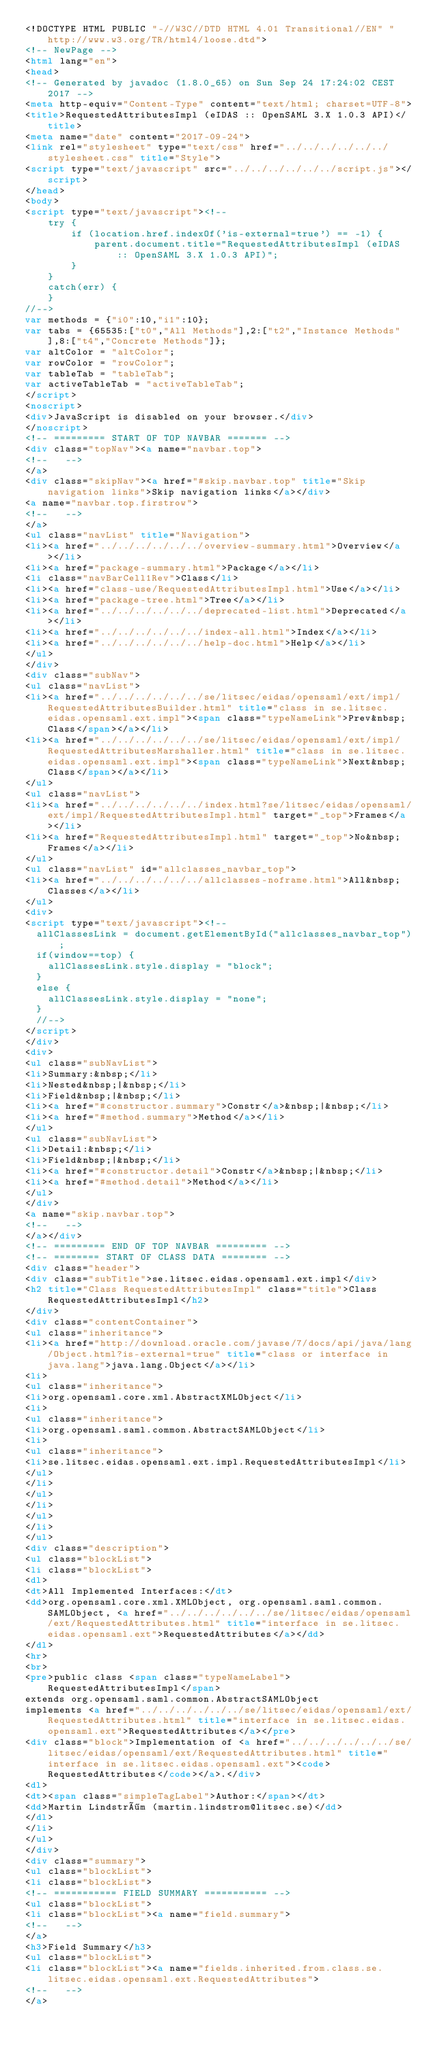Convert code to text. <code><loc_0><loc_0><loc_500><loc_500><_HTML_><!DOCTYPE HTML PUBLIC "-//W3C//DTD HTML 4.01 Transitional//EN" "http://www.w3.org/TR/html4/loose.dtd">
<!-- NewPage -->
<html lang="en">
<head>
<!-- Generated by javadoc (1.8.0_65) on Sun Sep 24 17:24:02 CEST 2017 -->
<meta http-equiv="Content-Type" content="text/html; charset=UTF-8">
<title>RequestedAttributesImpl (eIDAS :: OpenSAML 3.X 1.0.3 API)</title>
<meta name="date" content="2017-09-24">
<link rel="stylesheet" type="text/css" href="../../../../../../stylesheet.css" title="Style">
<script type="text/javascript" src="../../../../../../script.js"></script>
</head>
<body>
<script type="text/javascript"><!--
    try {
        if (location.href.indexOf('is-external=true') == -1) {
            parent.document.title="RequestedAttributesImpl (eIDAS :: OpenSAML 3.X 1.0.3 API)";
        }
    }
    catch(err) {
    }
//-->
var methods = {"i0":10,"i1":10};
var tabs = {65535:["t0","All Methods"],2:["t2","Instance Methods"],8:["t4","Concrete Methods"]};
var altColor = "altColor";
var rowColor = "rowColor";
var tableTab = "tableTab";
var activeTableTab = "activeTableTab";
</script>
<noscript>
<div>JavaScript is disabled on your browser.</div>
</noscript>
<!-- ========= START OF TOP NAVBAR ======= -->
<div class="topNav"><a name="navbar.top">
<!--   -->
</a>
<div class="skipNav"><a href="#skip.navbar.top" title="Skip navigation links">Skip navigation links</a></div>
<a name="navbar.top.firstrow">
<!--   -->
</a>
<ul class="navList" title="Navigation">
<li><a href="../../../../../../overview-summary.html">Overview</a></li>
<li><a href="package-summary.html">Package</a></li>
<li class="navBarCell1Rev">Class</li>
<li><a href="class-use/RequestedAttributesImpl.html">Use</a></li>
<li><a href="package-tree.html">Tree</a></li>
<li><a href="../../../../../../deprecated-list.html">Deprecated</a></li>
<li><a href="../../../../../../index-all.html">Index</a></li>
<li><a href="../../../../../../help-doc.html">Help</a></li>
</ul>
</div>
<div class="subNav">
<ul class="navList">
<li><a href="../../../../../../se/litsec/eidas/opensaml/ext/impl/RequestedAttributesBuilder.html" title="class in se.litsec.eidas.opensaml.ext.impl"><span class="typeNameLink">Prev&nbsp;Class</span></a></li>
<li><a href="../../../../../../se/litsec/eidas/opensaml/ext/impl/RequestedAttributesMarshaller.html" title="class in se.litsec.eidas.opensaml.ext.impl"><span class="typeNameLink">Next&nbsp;Class</span></a></li>
</ul>
<ul class="navList">
<li><a href="../../../../../../index.html?se/litsec/eidas/opensaml/ext/impl/RequestedAttributesImpl.html" target="_top">Frames</a></li>
<li><a href="RequestedAttributesImpl.html" target="_top">No&nbsp;Frames</a></li>
</ul>
<ul class="navList" id="allclasses_navbar_top">
<li><a href="../../../../../../allclasses-noframe.html">All&nbsp;Classes</a></li>
</ul>
<div>
<script type="text/javascript"><!--
  allClassesLink = document.getElementById("allclasses_navbar_top");
  if(window==top) {
    allClassesLink.style.display = "block";
  }
  else {
    allClassesLink.style.display = "none";
  }
  //-->
</script>
</div>
<div>
<ul class="subNavList">
<li>Summary:&nbsp;</li>
<li>Nested&nbsp;|&nbsp;</li>
<li>Field&nbsp;|&nbsp;</li>
<li><a href="#constructor.summary">Constr</a>&nbsp;|&nbsp;</li>
<li><a href="#method.summary">Method</a></li>
</ul>
<ul class="subNavList">
<li>Detail:&nbsp;</li>
<li>Field&nbsp;|&nbsp;</li>
<li><a href="#constructor.detail">Constr</a>&nbsp;|&nbsp;</li>
<li><a href="#method.detail">Method</a></li>
</ul>
</div>
<a name="skip.navbar.top">
<!--   -->
</a></div>
<!-- ========= END OF TOP NAVBAR ========= -->
<!-- ======== START OF CLASS DATA ======== -->
<div class="header">
<div class="subTitle">se.litsec.eidas.opensaml.ext.impl</div>
<h2 title="Class RequestedAttributesImpl" class="title">Class RequestedAttributesImpl</h2>
</div>
<div class="contentContainer">
<ul class="inheritance">
<li><a href="http://download.oracle.com/javase/7/docs/api/java/lang/Object.html?is-external=true" title="class or interface in java.lang">java.lang.Object</a></li>
<li>
<ul class="inheritance">
<li>org.opensaml.core.xml.AbstractXMLObject</li>
<li>
<ul class="inheritance">
<li>org.opensaml.saml.common.AbstractSAMLObject</li>
<li>
<ul class="inheritance">
<li>se.litsec.eidas.opensaml.ext.impl.RequestedAttributesImpl</li>
</ul>
</li>
</ul>
</li>
</ul>
</li>
</ul>
<div class="description">
<ul class="blockList">
<li class="blockList">
<dl>
<dt>All Implemented Interfaces:</dt>
<dd>org.opensaml.core.xml.XMLObject, org.opensaml.saml.common.SAMLObject, <a href="../../../../../../se/litsec/eidas/opensaml/ext/RequestedAttributes.html" title="interface in se.litsec.eidas.opensaml.ext">RequestedAttributes</a></dd>
</dl>
<hr>
<br>
<pre>public class <span class="typeNameLabel">RequestedAttributesImpl</span>
extends org.opensaml.saml.common.AbstractSAMLObject
implements <a href="../../../../../../se/litsec/eidas/opensaml/ext/RequestedAttributes.html" title="interface in se.litsec.eidas.opensaml.ext">RequestedAttributes</a></pre>
<div class="block">Implementation of <a href="../../../../../../se/litsec/eidas/opensaml/ext/RequestedAttributes.html" title="interface in se.litsec.eidas.opensaml.ext"><code>RequestedAttributes</code></a>.</div>
<dl>
<dt><span class="simpleTagLabel">Author:</span></dt>
<dd>Martin Lindström (martin.lindstrom@litsec.se)</dd>
</dl>
</li>
</ul>
</div>
<div class="summary">
<ul class="blockList">
<li class="blockList">
<!-- =========== FIELD SUMMARY =========== -->
<ul class="blockList">
<li class="blockList"><a name="field.summary">
<!--   -->
</a>
<h3>Field Summary</h3>
<ul class="blockList">
<li class="blockList"><a name="fields.inherited.from.class.se.litsec.eidas.opensaml.ext.RequestedAttributes">
<!--   -->
</a></code> 